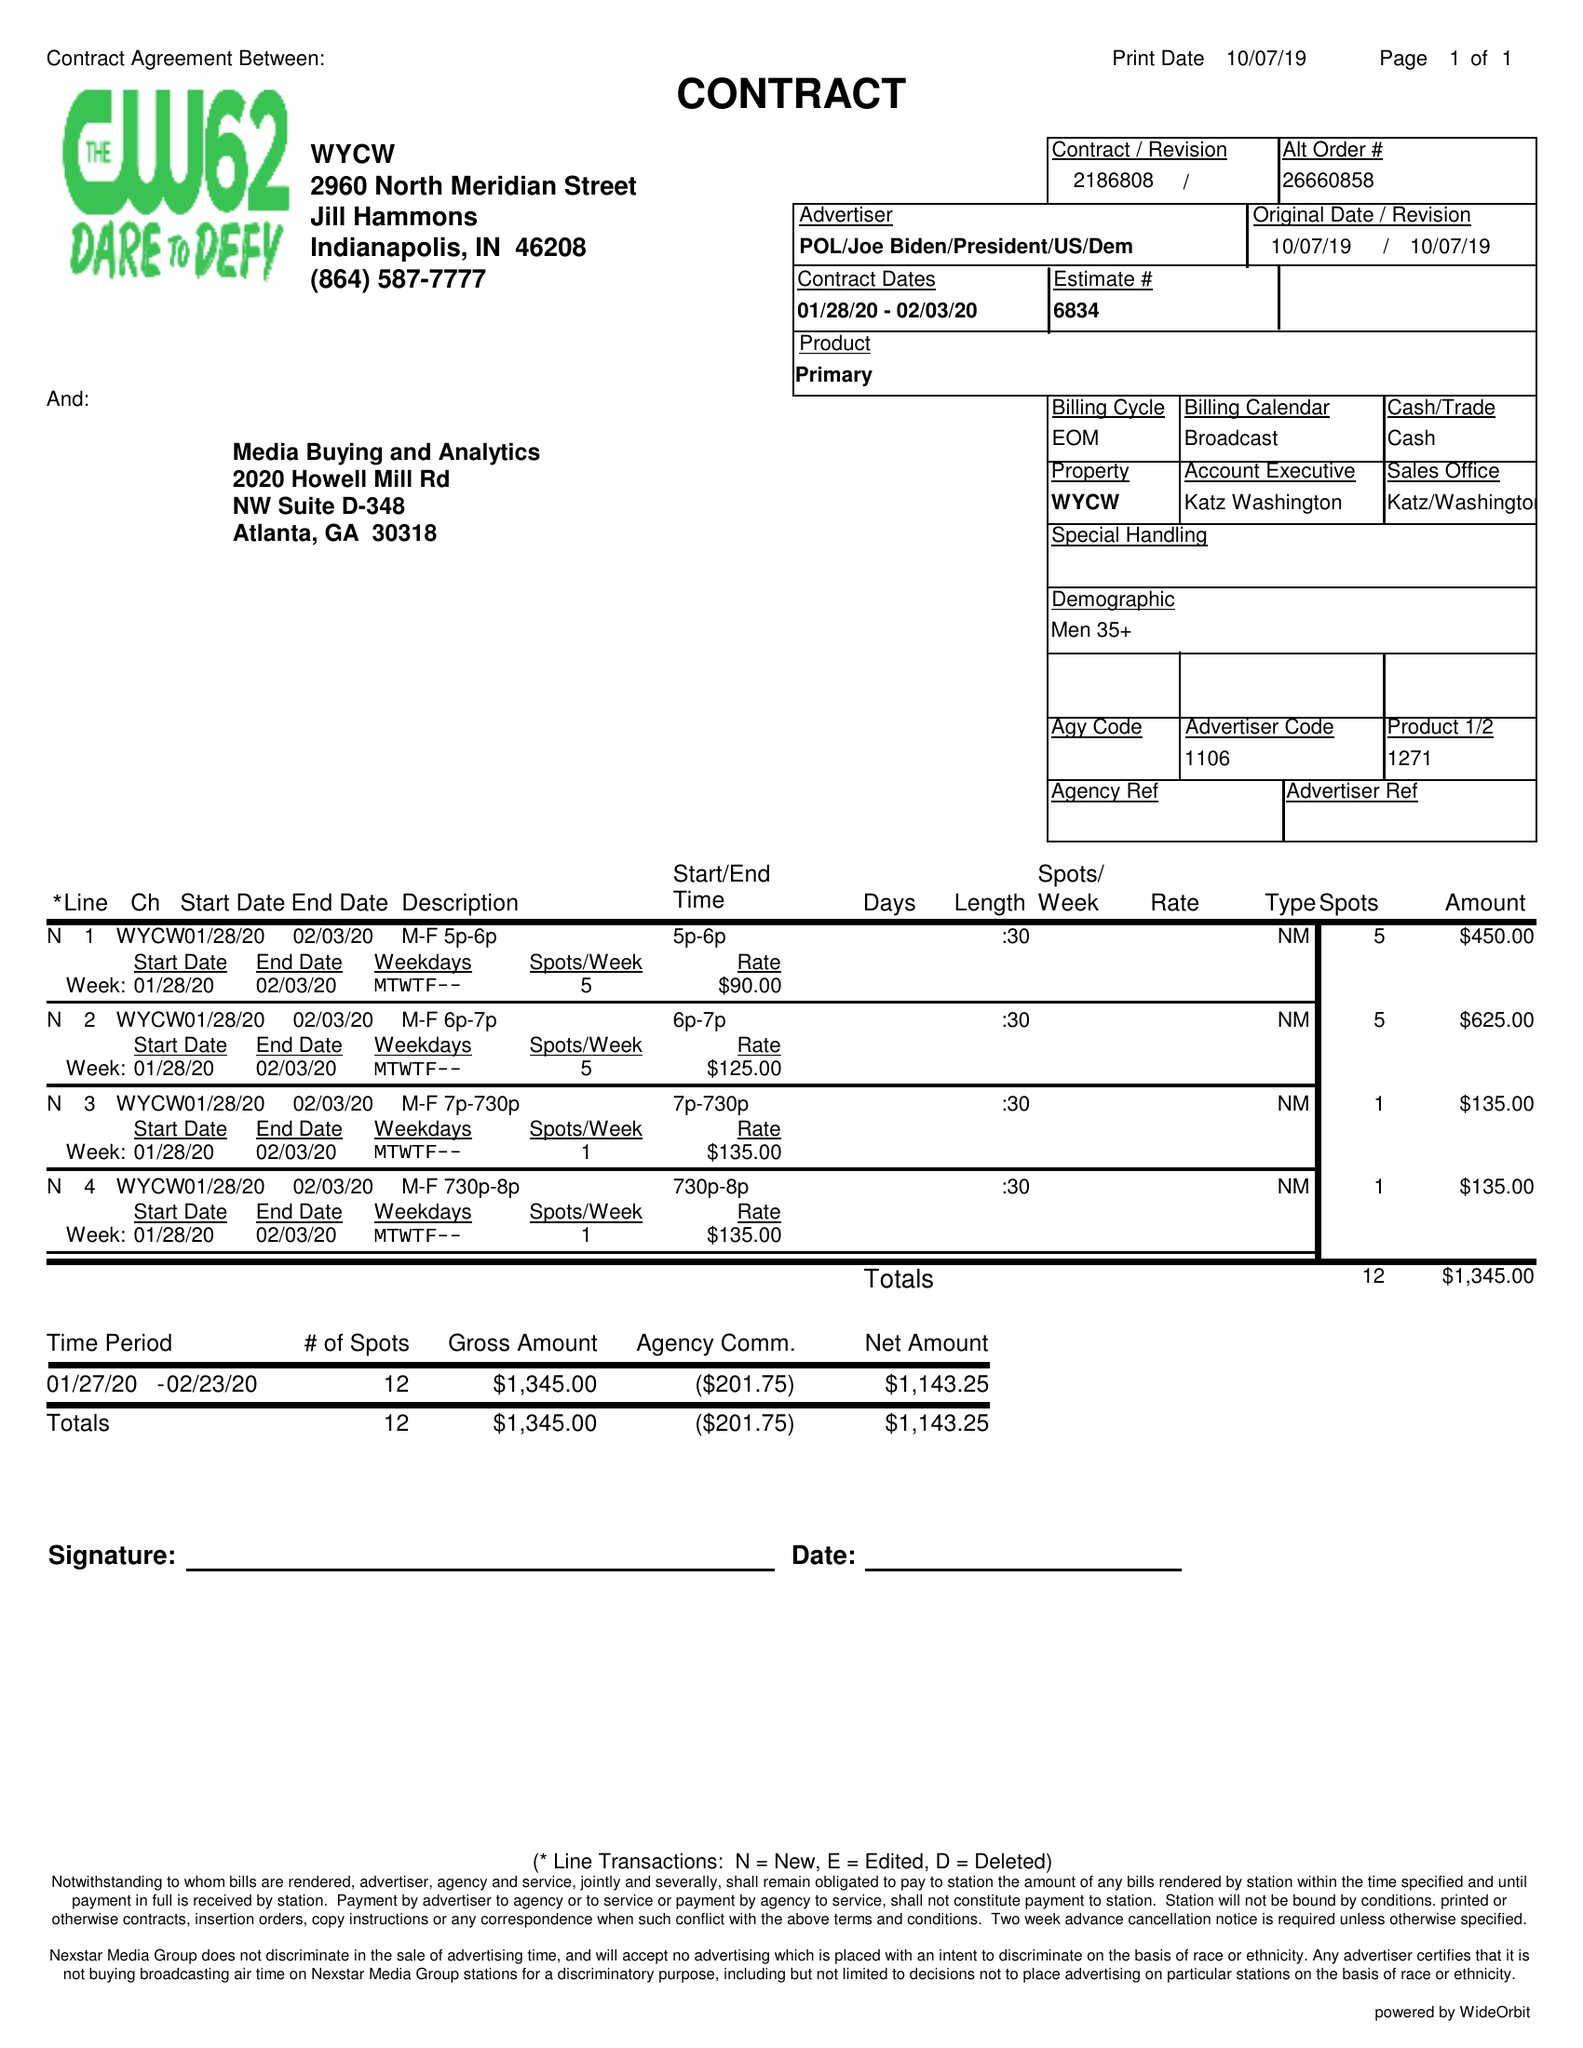What is the value for the advertiser?
Answer the question using a single word or phrase. POL/JOEBIDEN/PRESIDENT/US/DEM 